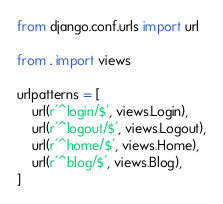<code> <loc_0><loc_0><loc_500><loc_500><_Python_>from django.conf.urls import url

from . import views

urlpatterns = [
    url(r'^login/$', views.Login),
    url(r'^logout/$', views.Logout),
    url(r'^home/$', views.Home),
    url(r'^blog/$', views.Blog),
]</code> 